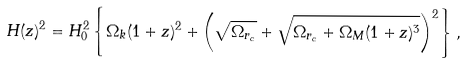<formula> <loc_0><loc_0><loc_500><loc_500>H ( z ) ^ { 2 } = H _ { 0 } ^ { 2 } \left \{ \Omega _ { k } ( 1 + z ) ^ { 2 } + \left ( \sqrt { \Omega _ { r _ { c } } } + \sqrt { \Omega _ { r _ { c } } + \Omega _ { M } ( 1 + z ) ^ { 3 } } \right ) ^ { 2 } \right \} ,</formula> 